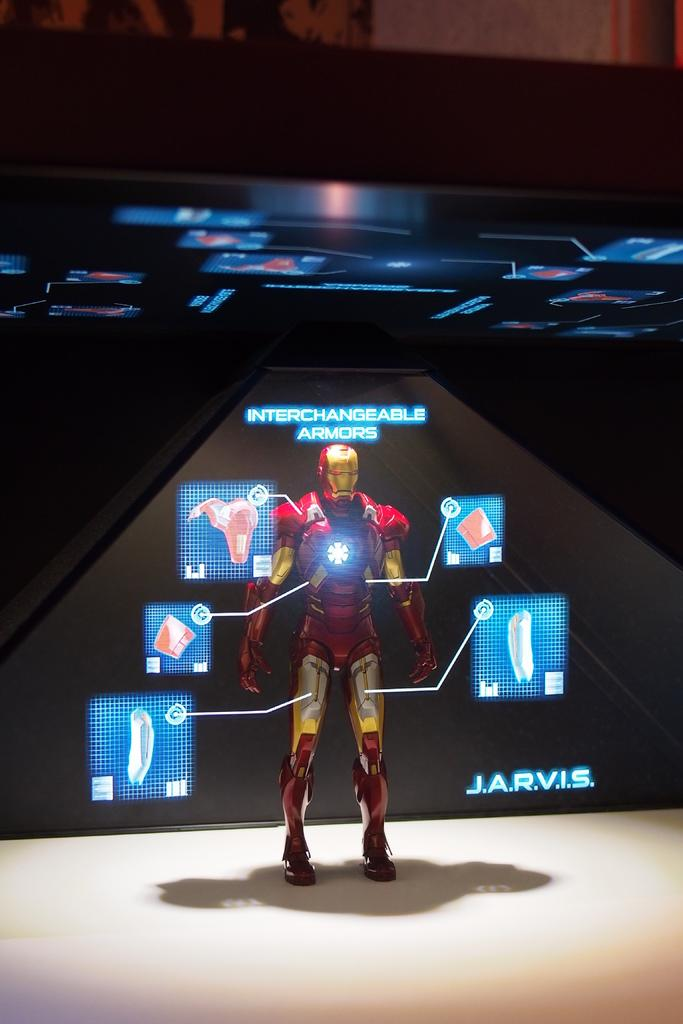<image>
Describe the image concisely. A display of a figure wearing red and gold interchangeable armor. 